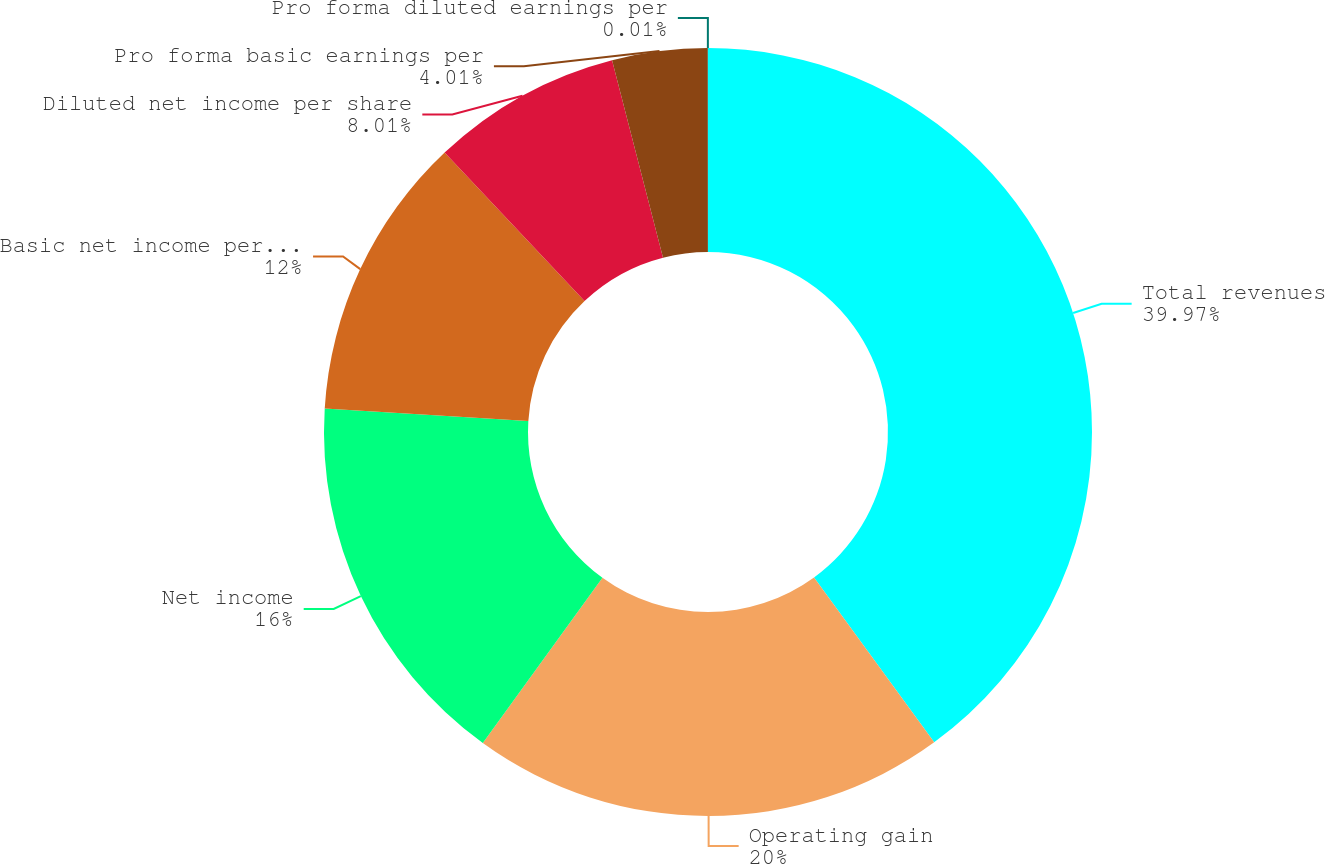<chart> <loc_0><loc_0><loc_500><loc_500><pie_chart><fcel>Total revenues<fcel>Operating gain<fcel>Net income<fcel>Basic net income per share<fcel>Diluted net income per share<fcel>Pro forma basic earnings per<fcel>Pro forma diluted earnings per<nl><fcel>39.98%<fcel>20.0%<fcel>16.0%<fcel>12.0%<fcel>8.01%<fcel>4.01%<fcel>0.01%<nl></chart> 